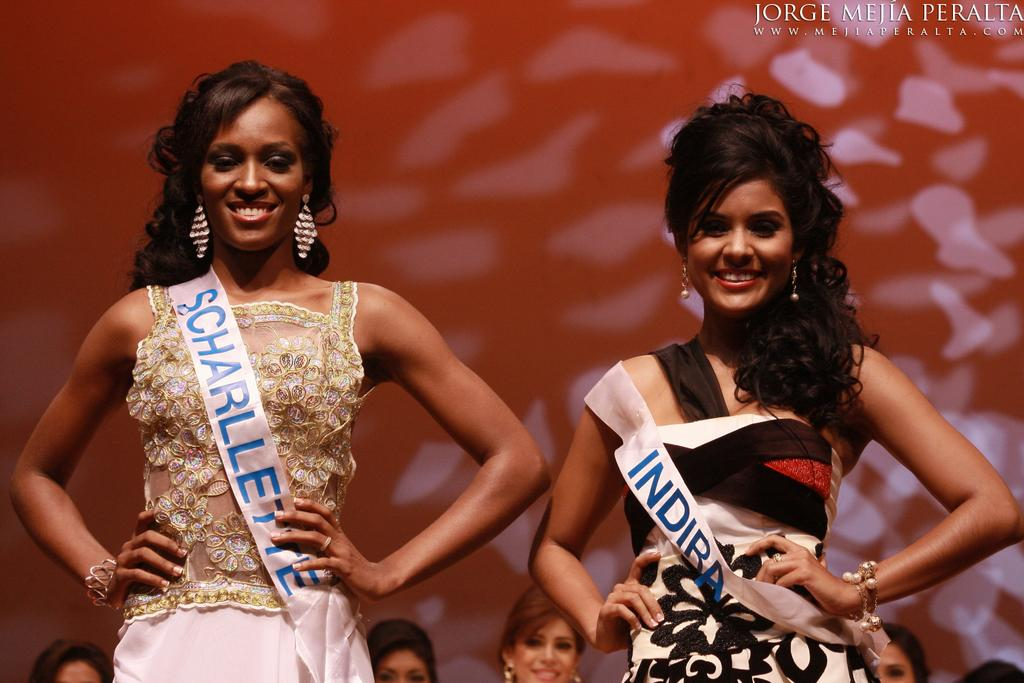How many women are in the image? There are two women in the image. What are the women doing in the image? The women are posing for a photograph. Can you describe the background of the image? There are people and a wall in the background of the image. Is there any text visible in the image? Yes, there is some text in the top right corner of the image. Can you tell me what type of donkey is featured in the image? There is no donkey present in the image. What kind of shop can be seen in the background of the image? There is no shop visible in the image; only people, a wall, and text are present. 